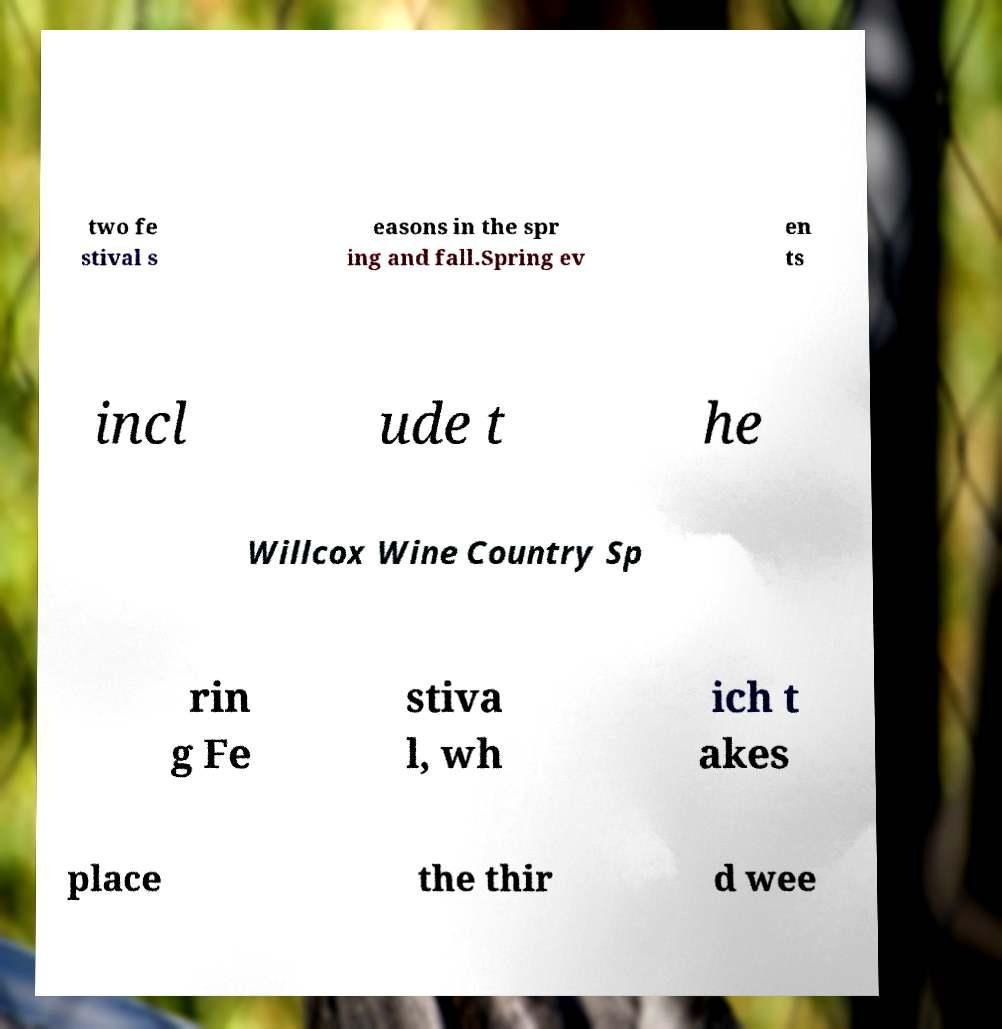Please read and relay the text visible in this image. What does it say? two fe stival s easons in the spr ing and fall.Spring ev en ts incl ude t he Willcox Wine Country Sp rin g Fe stiva l, wh ich t akes place the thir d wee 